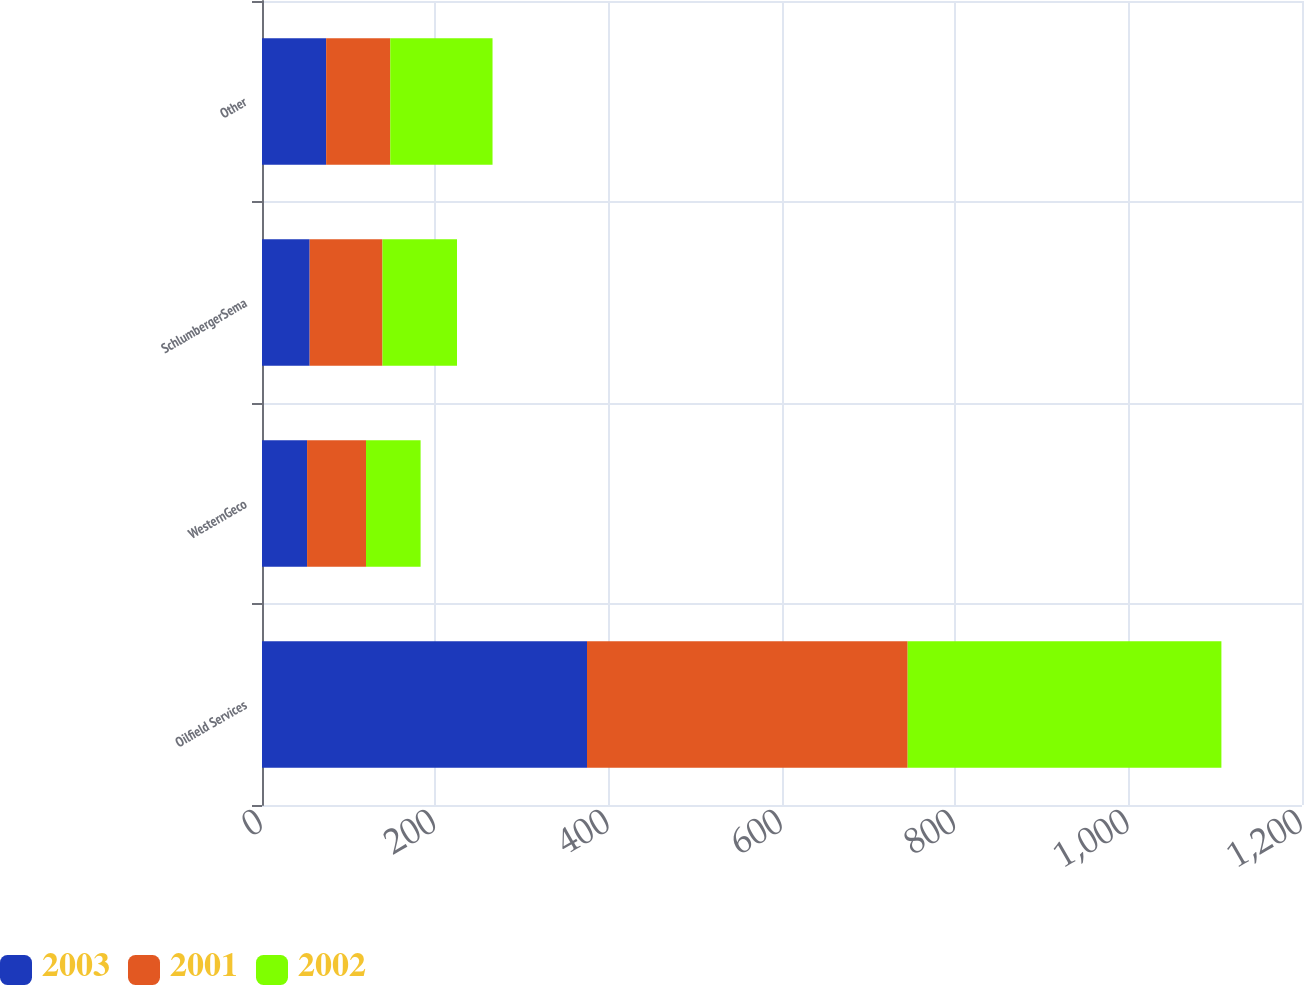Convert chart to OTSL. <chart><loc_0><loc_0><loc_500><loc_500><stacked_bar_chart><ecel><fcel>Oilfield Services<fcel>WesternGeco<fcel>SchlumbergerSema<fcel>Other<nl><fcel>2003<fcel>375<fcel>52<fcel>55<fcel>74<nl><fcel>2001<fcel>370<fcel>68<fcel>84<fcel>74<nl><fcel>2002<fcel>362<fcel>63<fcel>86<fcel>118<nl></chart> 